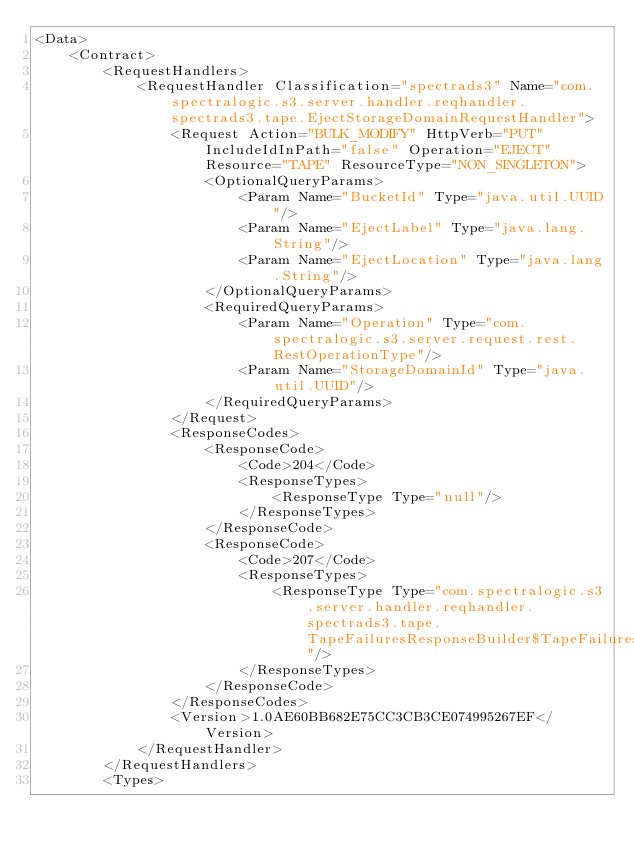<code> <loc_0><loc_0><loc_500><loc_500><_XML_><Data>
    <Contract>
        <RequestHandlers>
            <RequestHandler Classification="spectrads3" Name="com.spectralogic.s3.server.handler.reqhandler.spectrads3.tape.EjectStorageDomainRequestHandler">
                <Request Action="BULK_MODIFY" HttpVerb="PUT" IncludeIdInPath="false" Operation="EJECT" Resource="TAPE" ResourceType="NON_SINGLETON">
                    <OptionalQueryParams>
                        <Param Name="BucketId" Type="java.util.UUID"/>
                        <Param Name="EjectLabel" Type="java.lang.String"/>
                        <Param Name="EjectLocation" Type="java.lang.String"/>
                    </OptionalQueryParams>
                    <RequiredQueryParams>
                        <Param Name="Operation" Type="com.spectralogic.s3.server.request.rest.RestOperationType"/>
                        <Param Name="StorageDomainId" Type="java.util.UUID"/>
                    </RequiredQueryParams>
                </Request>
                <ResponseCodes>
                    <ResponseCode>
                        <Code>204</Code>
                        <ResponseTypes>
                            <ResponseType Type="null"/>
                        </ResponseTypes>
                    </ResponseCode>
                    <ResponseCode>
                        <Code>207</Code>
                        <ResponseTypes>
                            <ResponseType Type="com.spectralogic.s3.server.handler.reqhandler.spectrads3.tape.TapeFailuresResponseBuilder$TapeFailuresApiBean"/>
                        </ResponseTypes>
                    </ResponseCode>
                </ResponseCodes>
                <Version>1.0AE60BB682E75CC3CB3CE074995267EF</Version>
            </RequestHandler>
        </RequestHandlers>
        <Types></code> 